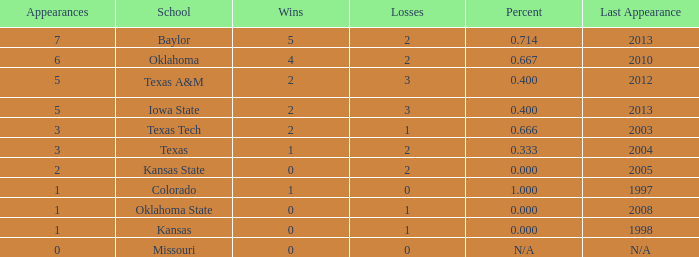How many schools had the win loss ratio of 0.667?  1.0. 